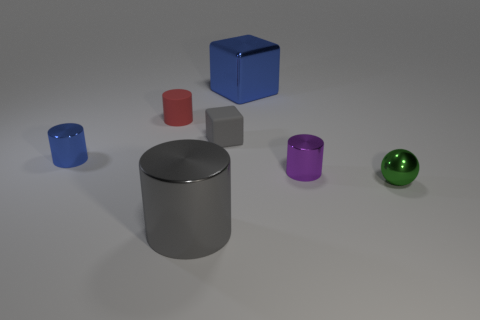Subtract all cyan cylinders. Subtract all red balls. How many cylinders are left? 4 Add 3 small blue objects. How many objects exist? 10 Subtract all cubes. How many objects are left? 5 Add 3 large cubes. How many large cubes are left? 4 Add 1 small brown metallic things. How many small brown metallic things exist? 1 Subtract 0 brown spheres. How many objects are left? 7 Subtract all tiny purple objects. Subtract all tiny blue metal cylinders. How many objects are left? 5 